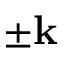Convert formula to latex. <formula><loc_0><loc_0><loc_500><loc_500>\pm k</formula> 